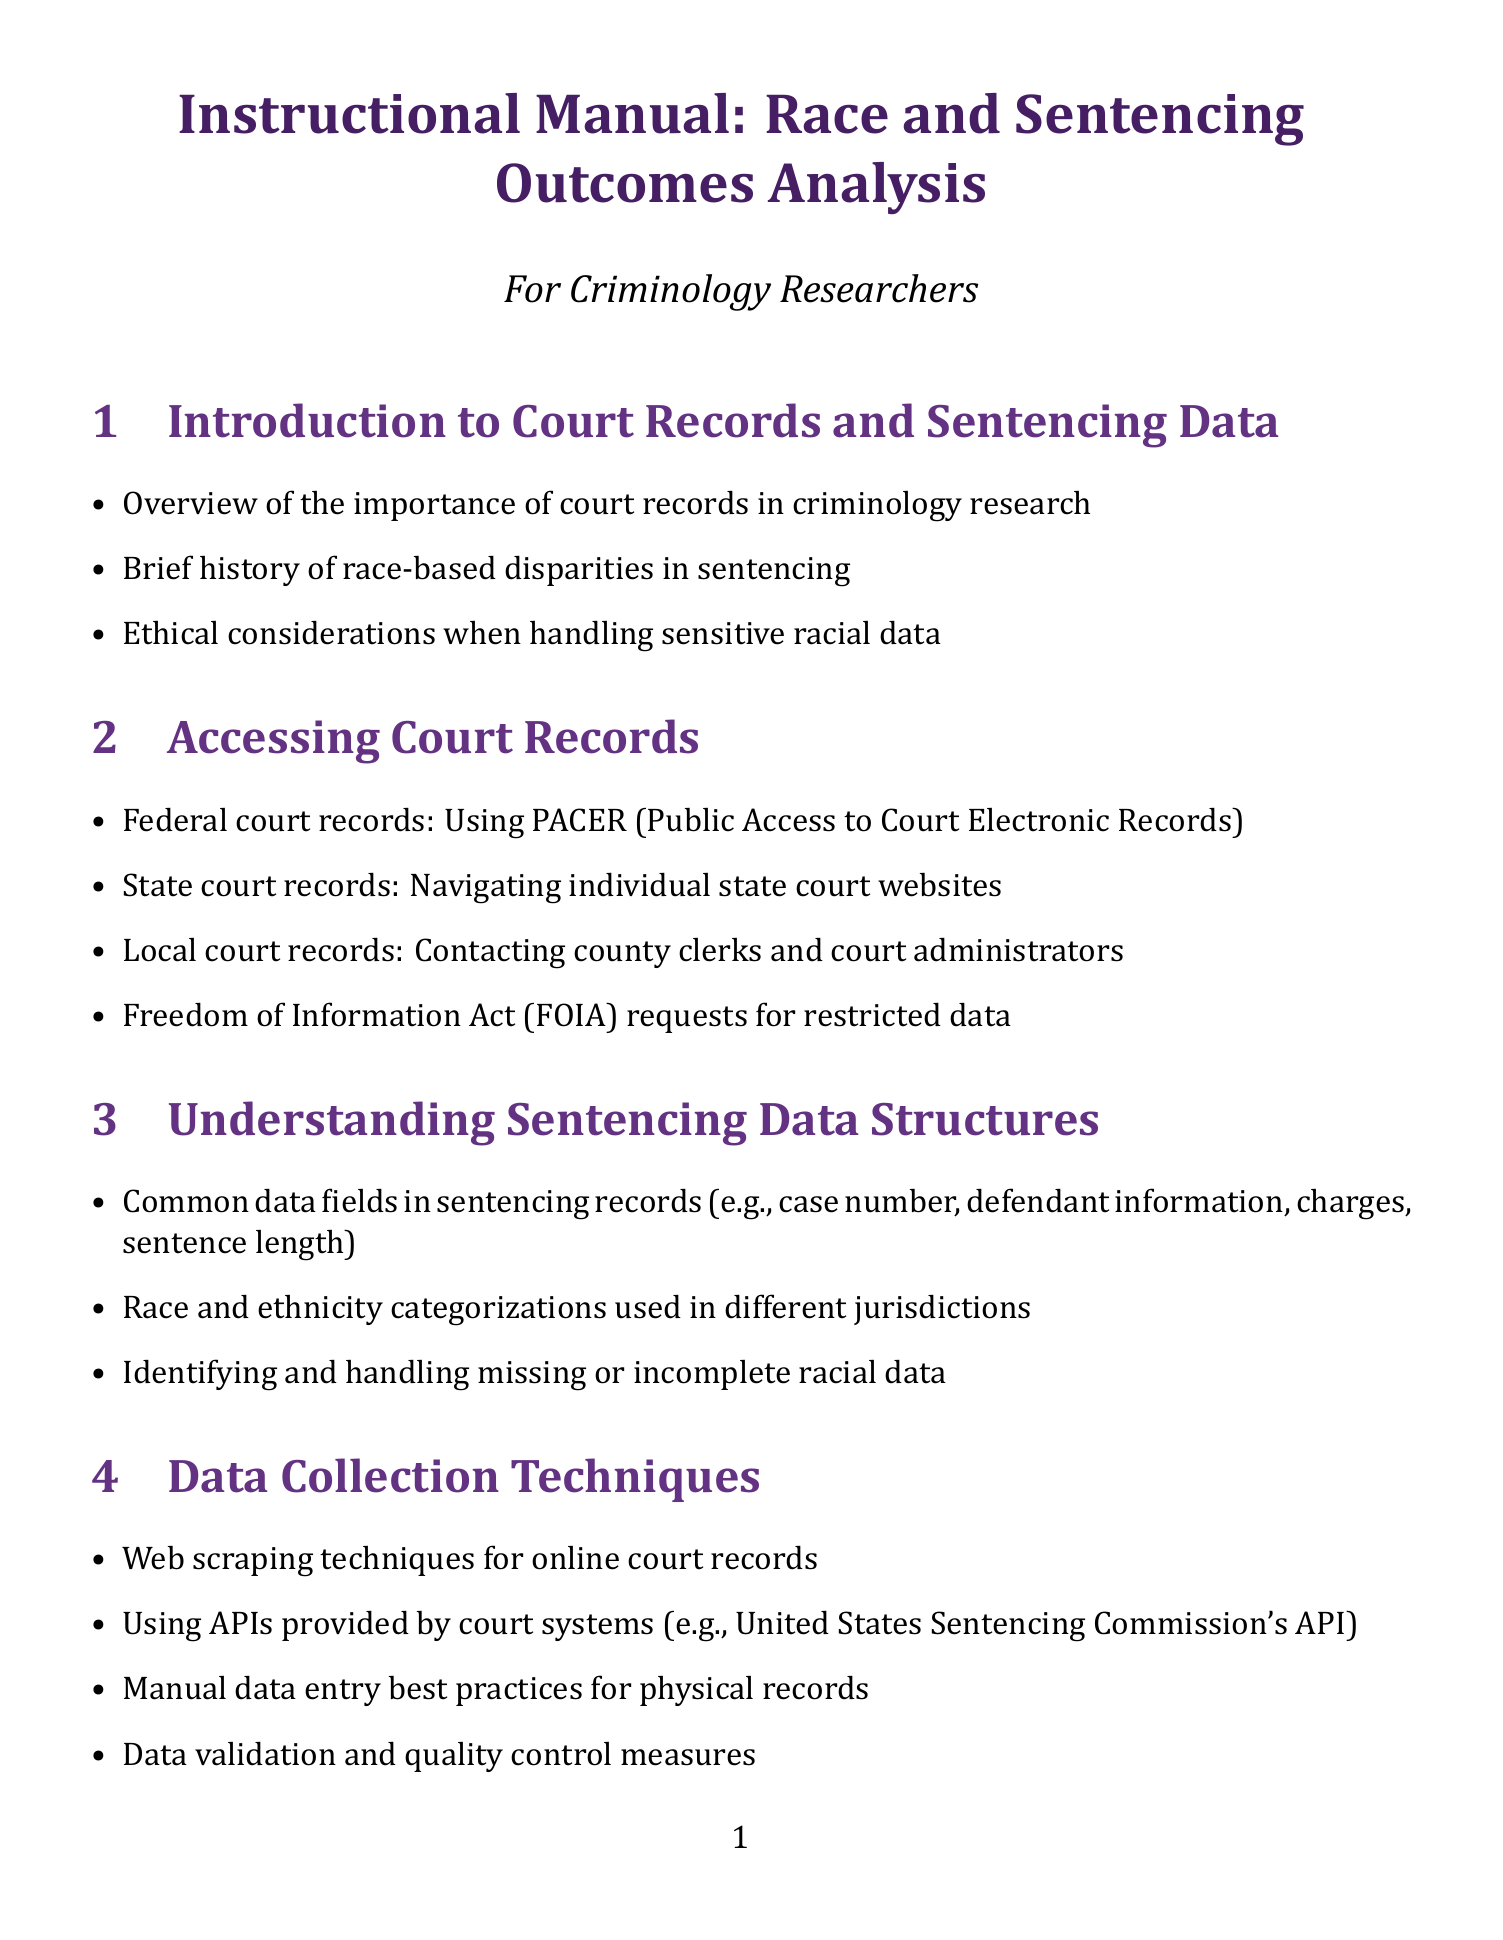What is the title of the manual? The title of the manual is specified at the beginning of the document.
Answer: Instructional Manual: Race and Sentencing Outcomes Analysis What is the first section of the manual? The first section is listed in the table of contents, outlining the main topics covered.
Answer: Introduction to Court Records and Sentencing Data Which software is introduced for statistical analysis? The manual lists various software tools for data analysis within the relevant section.
Answer: R and RStudio What statistical concept is emphasized for sentencing analysis? The document covers basic statistical concepts that are crucial for analyzing sentencing data.
Answer: Mean Which case study is mentioned regarding federal drug sentencing? Specific case studies are outlined in their dedicated section to illustrate racial disparities.
Answer: Analysis of racial disparities in federal drug sentencing How many advanced analysis techniques are mentioned? The advanced analysis section enumerates various techniques applicable to the data.
Answer: Four What ethical consideration is highlighted in the manual? A section is dedicated to legal and ethical aspects of handling sensitive data in research.
Answer: Protecting individual privacy in sentencing research What type of analysis is used to identify sentencing disparities? The manual suggests various methods to determine disparities in sentencing across racial groups.
Answer: Geospatial analysis Who are the intended readers of the manual? The author notes the audience for whom the manual is designed at the beginning.
Answer: Criminology Researchers 